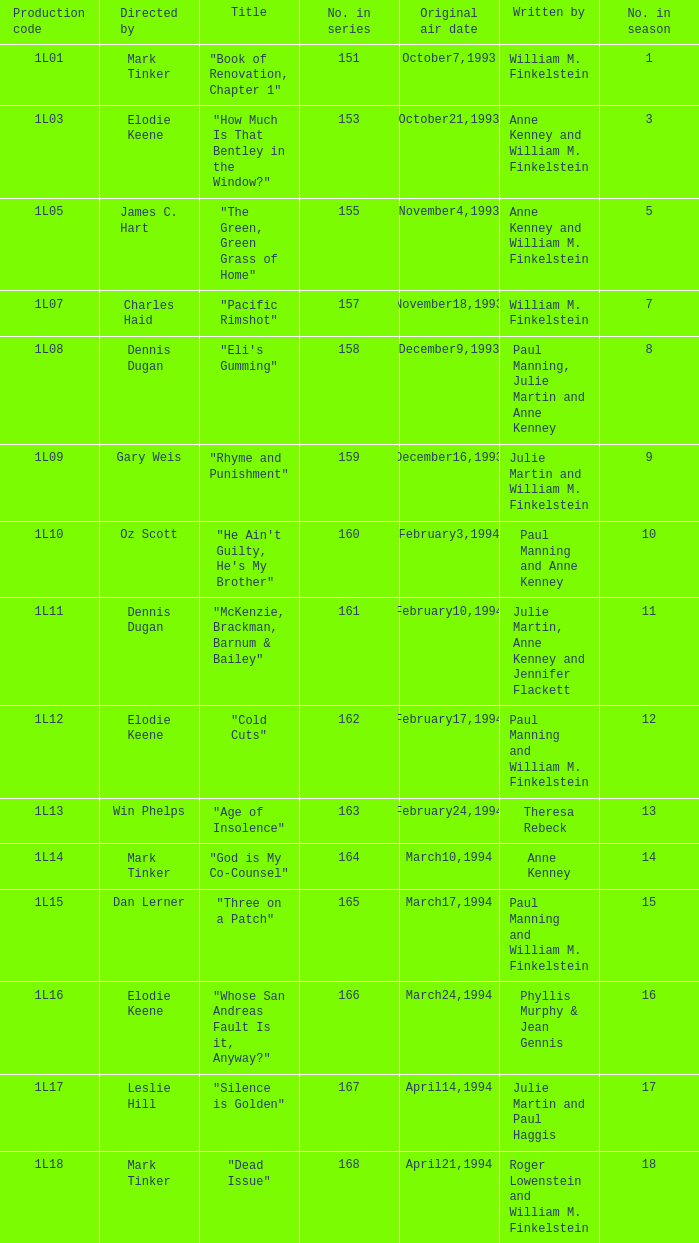Name the original air date for production code 1l16 March24,1994. 